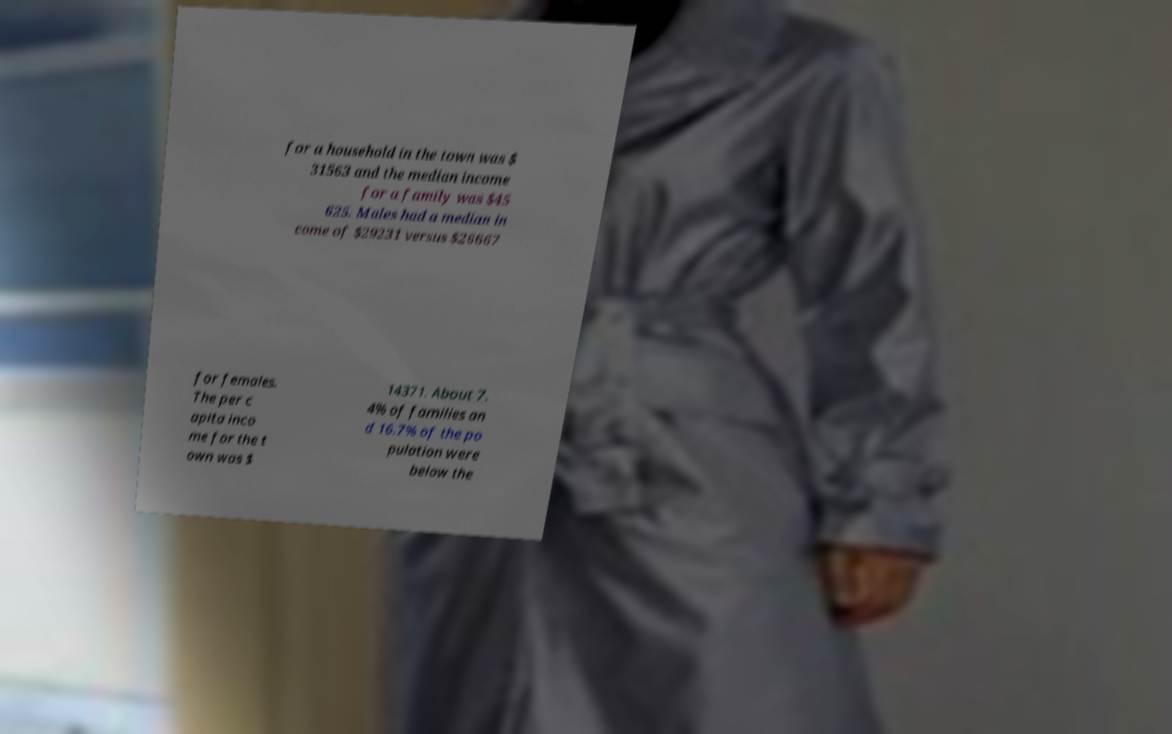There's text embedded in this image that I need extracted. Can you transcribe it verbatim? for a household in the town was $ 31563 and the median income for a family was $45 625. Males had a median in come of $29231 versus $26667 for females. The per c apita inco me for the t own was $ 14371. About 7. 4% of families an d 16.7% of the po pulation were below the 